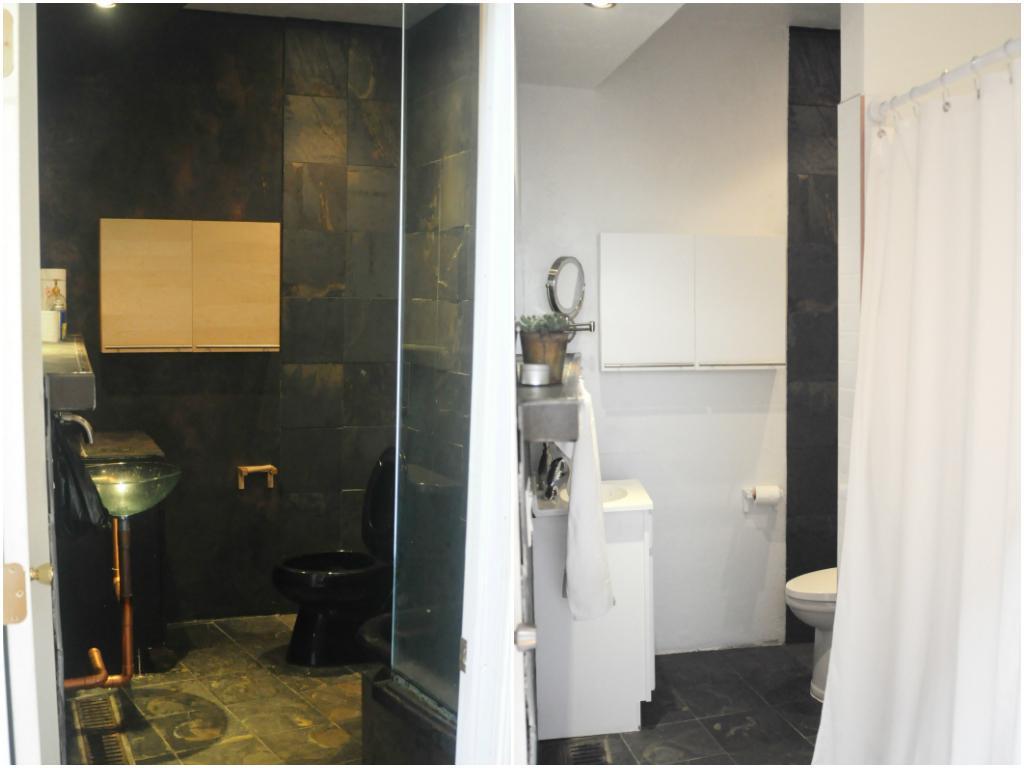Please provide a concise description of this image. In this image we can see a wash basin, a tap, a toilet seat, a door and a light to the ceiling on the left side of the image and on the right side of the image we can see a wash basin, a shelf with a potted plant, a mirror, a toilet paper, a toilet seat, a curtain to the rod and the light to the ceiling. 